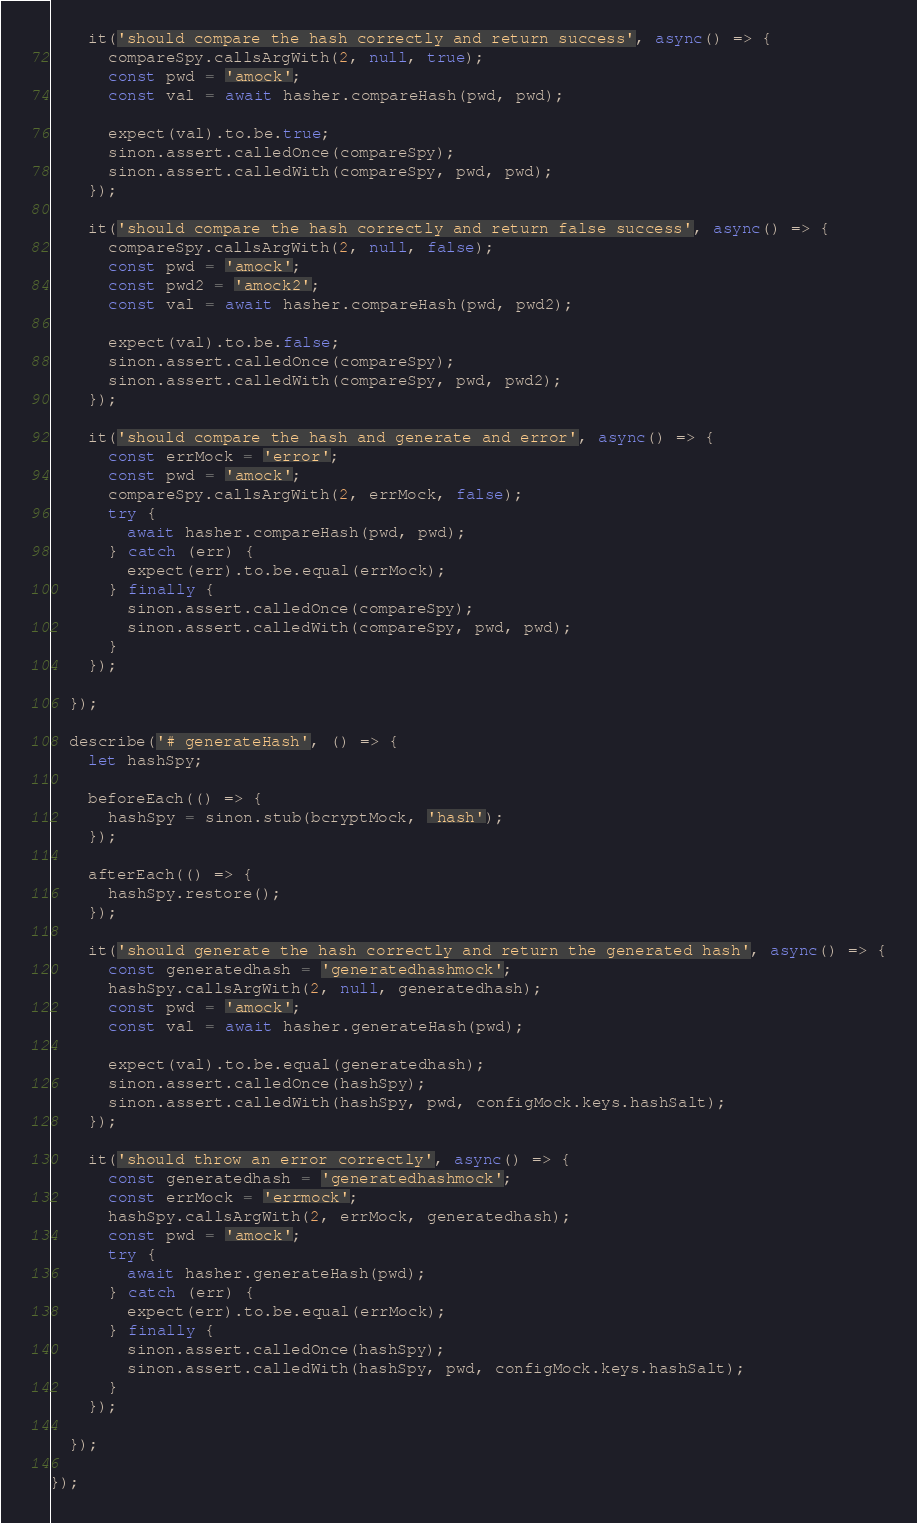Convert code to text. <code><loc_0><loc_0><loc_500><loc_500><_JavaScript_>
    it('should compare the hash correctly and return success', async() => {
      compareSpy.callsArgWith(2, null, true);
      const pwd = 'amock';
      const val = await hasher.compareHash(pwd, pwd);

      expect(val).to.be.true;
      sinon.assert.calledOnce(compareSpy);
      sinon.assert.calledWith(compareSpy, pwd, pwd);
    });

    it('should compare the hash correctly and return false success', async() => {
      compareSpy.callsArgWith(2, null, false);
      const pwd = 'amock';
      const pwd2 = 'amock2';
      const val = await hasher.compareHash(pwd, pwd2);

      expect(val).to.be.false;
      sinon.assert.calledOnce(compareSpy);
      sinon.assert.calledWith(compareSpy, pwd, pwd2);
    });

    it('should compare the hash and generate and error', async() => {
      const errMock = 'error';
      const pwd = 'amock';
      compareSpy.callsArgWith(2, errMock, false);
      try {
        await hasher.compareHash(pwd, pwd);
      } catch (err) {
        expect(err).to.be.equal(errMock);
      } finally {
        sinon.assert.calledOnce(compareSpy);
        sinon.assert.calledWith(compareSpy, pwd, pwd);
      }
    });

  });

  describe('# generateHash', () => {
    let hashSpy;

    beforeEach(() => {
      hashSpy = sinon.stub(bcryptMock, 'hash');
    });

    afterEach(() => {
      hashSpy.restore();
    });

    it('should generate the hash correctly and return the generated hash', async() => {
      const generatedhash = 'generatedhashmock';
      hashSpy.callsArgWith(2, null, generatedhash);
      const pwd = 'amock';
      const val = await hasher.generateHash(pwd);

      expect(val).to.be.equal(generatedhash);
      sinon.assert.calledOnce(hashSpy);
      sinon.assert.calledWith(hashSpy, pwd, configMock.keys.hashSalt);
    });

    it('should throw an error correctly', async() => {
      const generatedhash = 'generatedhashmock';
      const errMock = 'errmock';
      hashSpy.callsArgWith(2, errMock, generatedhash);
      const pwd = 'amock';
      try {
        await hasher.generateHash(pwd);
      } catch (err) {
        expect(err).to.be.equal(errMock);
      } finally {
        sinon.assert.calledOnce(hashSpy);
        sinon.assert.calledWith(hashSpy, pwd, configMock.keys.hashSalt);
      }
    });

  });

});
</code> 